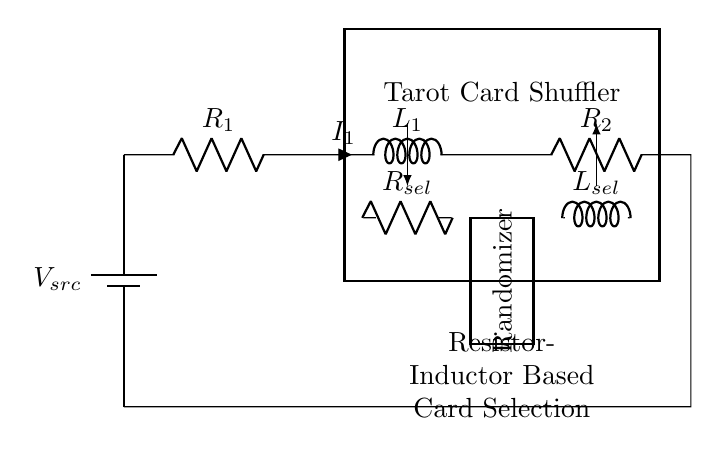What are the components in this circuit? The circuit consists of a battery, two resistors, and two inductors. The components are organized in a series layout where the battery acts as the power source.
Answer: battery, resistors, inductors What is the purpose of the resistor in the card selection mechanism? The resistor in the card selection mechanism is used to limit the current flowing through that part, which can help in controlling the operation of the card shuffling process.
Answer: limit current What does the label “Tarot Card Shuffler” represent in the diagram? The label “Tarot Card Shuffler” identifies the main component or section of the circuit that is dedicated to the randomization and selection of tarot cards.
Answer: shuffling mechanism How many resistors are present in the circuit? There are three resistors in the circuit: R1, R2, and Rsel. Each resistor plays a different role in the card shuffling process.
Answer: three What happens to the current in the circuit when either inductor is energized? When either inductor is energized, it will create a magnetic field that can oppose changes in current, which is a characteristic of inductors in a circuit. This may affect the overall current flow and create a delay in response.
Answer: opposes change Why is a randomizer included in this circuit? A randomizer is included to ensure that the card selection process is unpredictable, adding an element of randomness to the tarot card selection system, which is essential for fair play.
Answer: ensure unpredictability 